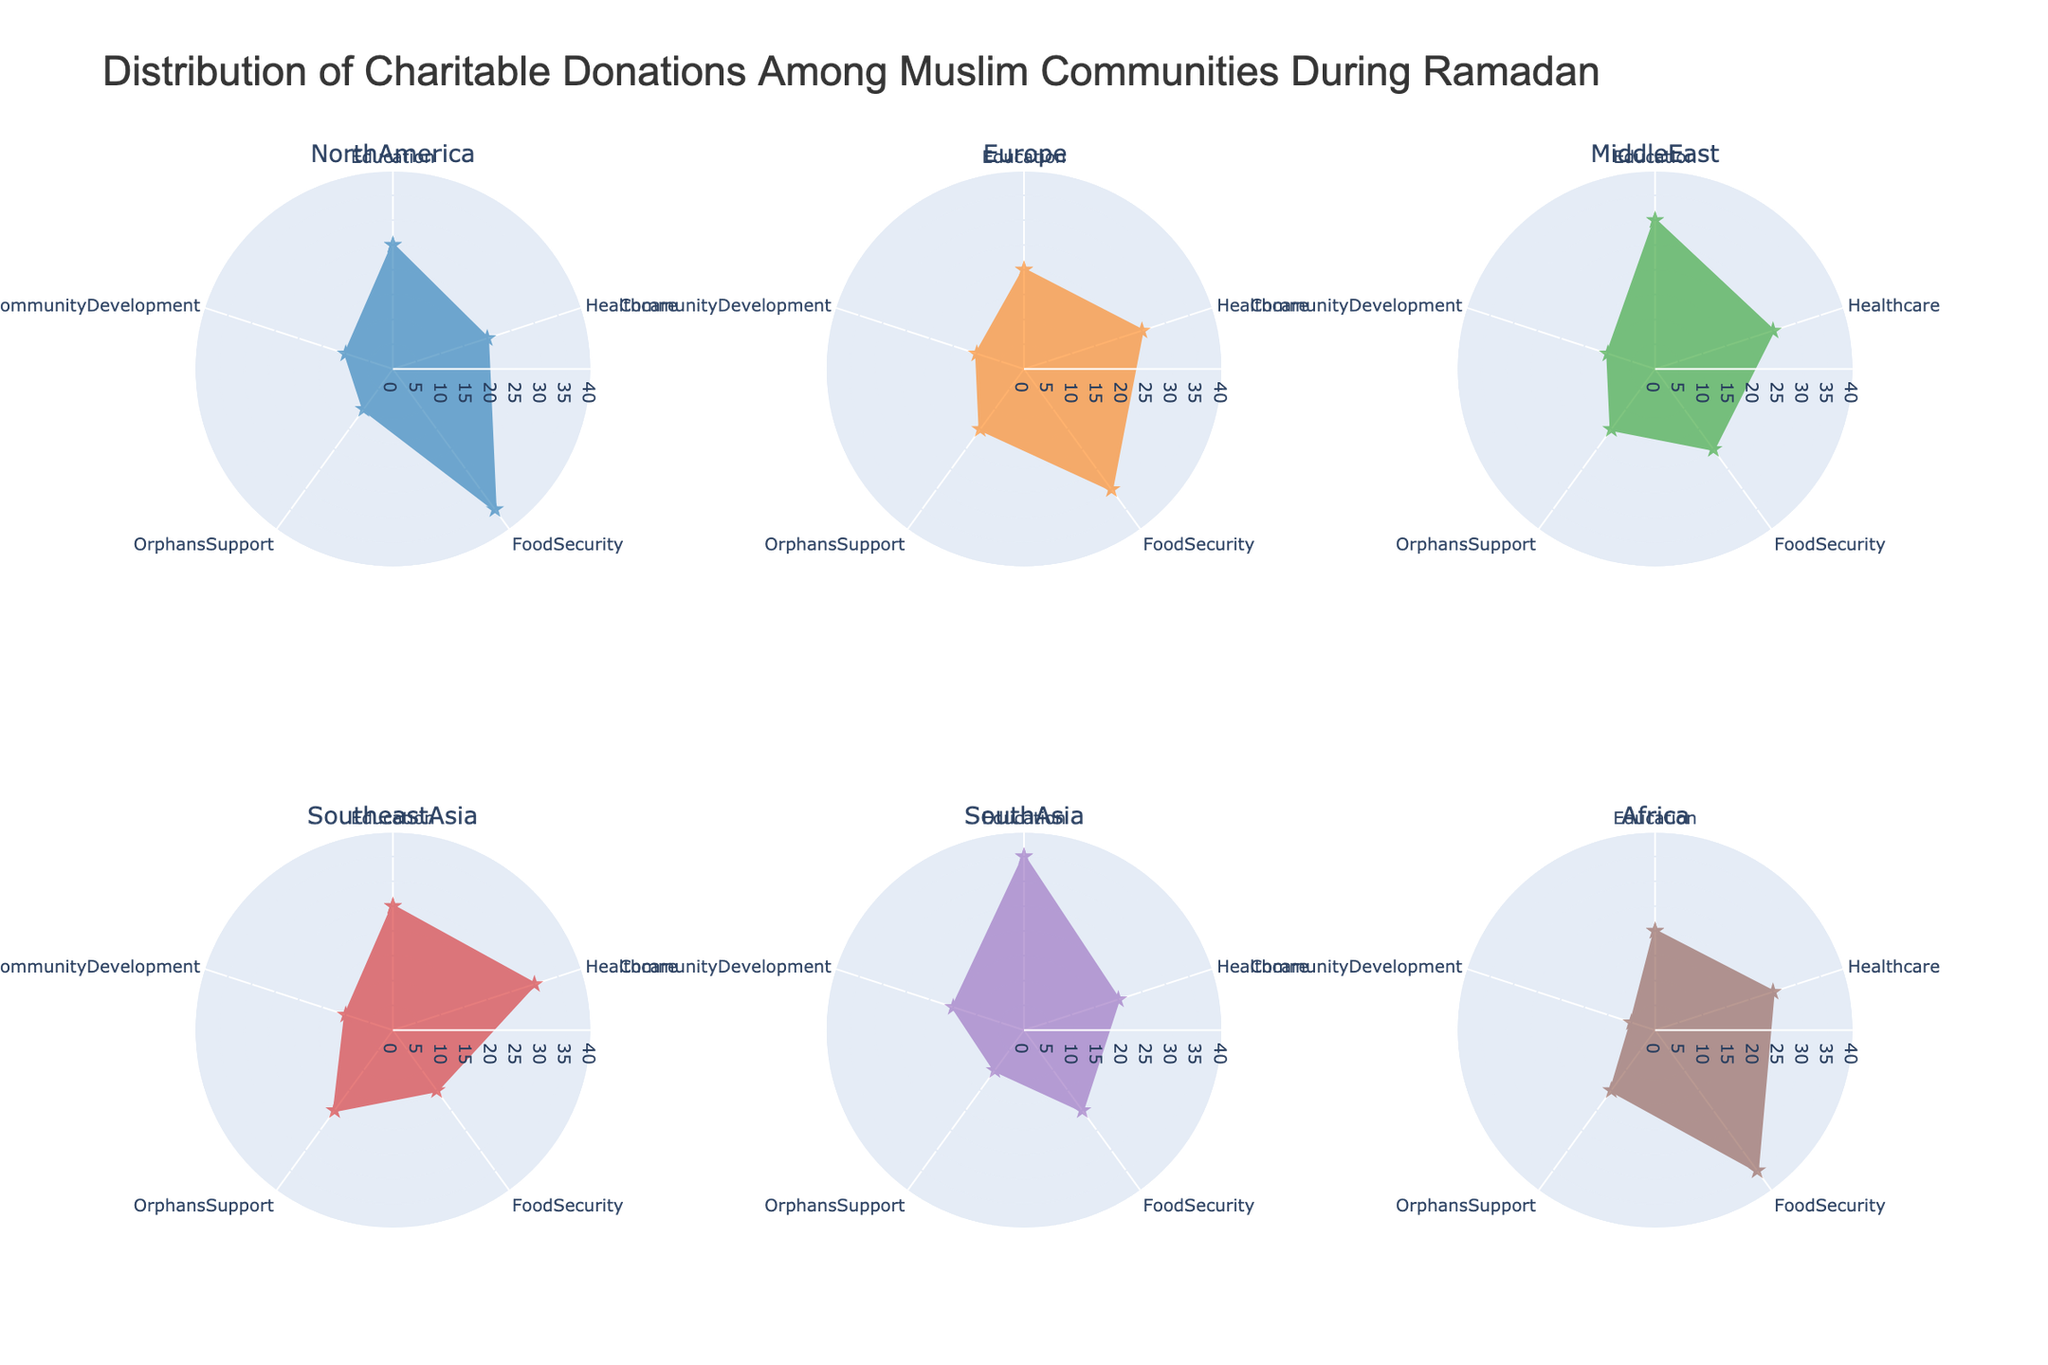What's the community with the highest donation for Education? By checking each subplot, the community with the highest value for Education can be identified. South Asia has the highest donation for Education.
Answer: South Asia Which community allocates the least percentage to Orphans Support? By looking at all the subplots, compare the values for Orphans Support. Africa allocates the least percentage to Orphans Support (5%).
Answer: Africa What is the average donation for Food Security among all communities? Sum the values for Food Security across all communities (35+30+20+15+20+35) and divide by the number of communities (6). The average donation for Food Security is (35+30+20+15+20+35)/6 = 25.83.
Answer: 25.83 Which category receives the most consistent donation across all communities? Consistency can be assessed by visual inspection, noting the smallest range between highest and lowest values across all subplots. CommunityDevelopment has values mostly between 10 and 15.
Answer: CommunityDevelopment Which community has the highest donation for Healthcare? By checking each subplot, the community with the highest value for Healthcare can be identified. Southeast Asia has the highest donation for Healthcare (30%).
Answer: Southeast Asia What's the total donation percentage for the North America community across all categories? Sum all the values for the North America community: 25 (Education) + 20 (Healthcare) + 35 (Food Security) + 10 (Orphans Support) + 10 (Community Development) = 100.
Answer: 100 How does the donation for Education compare between North America and Europe? Inspect the subplots for North America and Europe and compare the values for Education. North America has 25% and Europe has 20%. North America donates 5% more to Education than Europe does.
Answer: North America donates 5% more For the Middle East community, which category receives the most donations? Inspect the Middle East subplot to identify which category has the highest value. Education receives the highest donations at 30%.
Answer: Education Which community has the highest disparity between its highest and lowest donated categories? For each community, calculate the difference between the highest and lowest values. North America and Africa both show 35% disparity (highest 35% minus lowest 0%), but inspect other communities to verify.
Answer: North America and Africa What is the combined donation percentage for Community Development across Europe and South Asia? Sum the values for Community Development in the Europe and South Asia subplots: 10 (Europe) + 15 (South Asia) = 25.
Answer: 25 